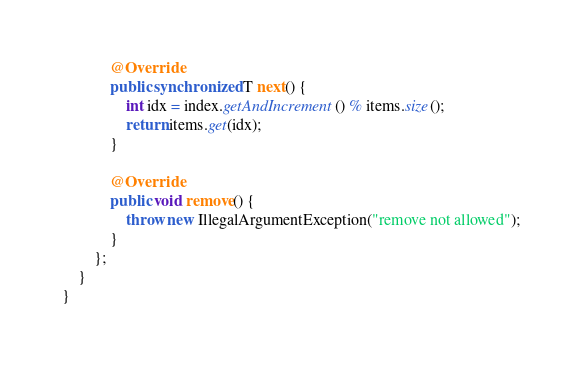Convert code to text. <code><loc_0><loc_0><loc_500><loc_500><_Java_>
            @Override
            public synchronized T next() {
                int idx = index.getAndIncrement() % items.size();
                return items.get(idx);
            }

            @Override
            public void remove() {
                throw new IllegalArgumentException("remove not allowed");
            }
        };
    }
}
</code> 